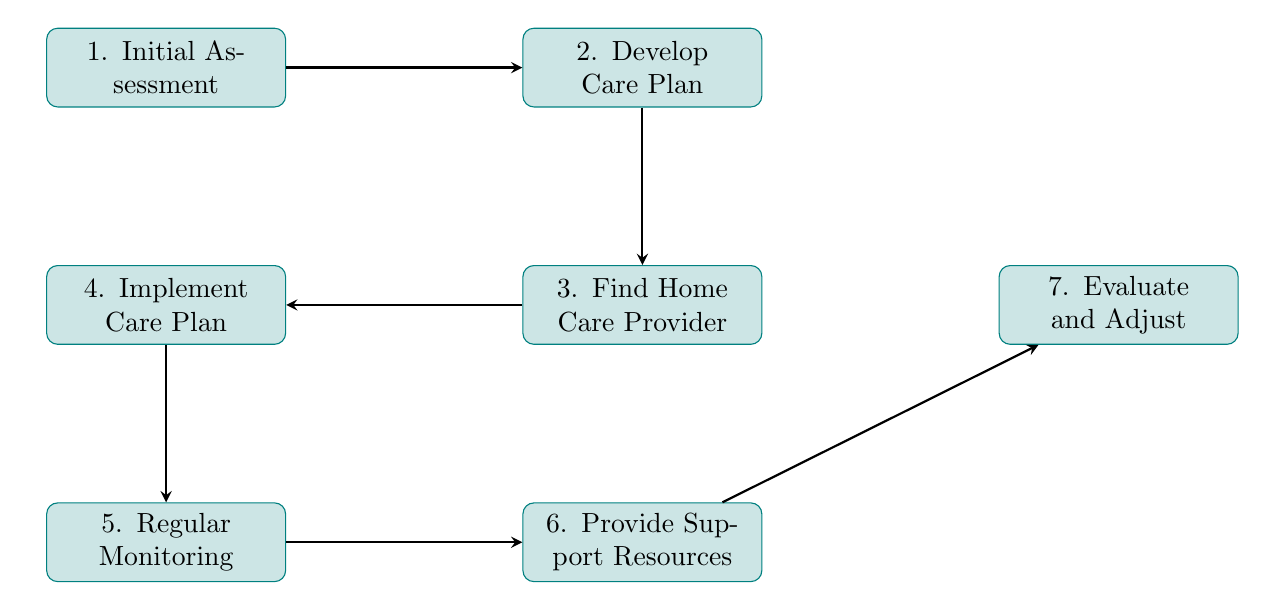What is the first step in the flow chart? The flow chart begins with the "Initial Assessment" node, which is the first step in the process.
Answer: Initial Assessment How many total nodes are in the diagram? There are seven nodes represented in the flow chart, each indicating a distinct step in the process.
Answer: 7 Which step follows "Develop Care Plan"? The step that follows "Develop Care Plan" is "Find Home Care Provider," indicating the progression in the process.
Answer: Find Home Care Provider What is the ultimate goal of the flow chart? The ultimate goal is demonstrated by the last node, "Evaluate and Adjust," which shows the ongoing nature of care coordination.
Answer: Evaluate and Adjust How many edges connect the nodes? The flow chart contains six edges that connect the seven nodes, indicating the relationships and flow between each step.
Answer: 6 What step directly leads to "Regular Monitoring"? The step that directly leads to "Regular Monitoring" is "Implement Care Plan," as indicated by the arrow connecting these two nodes.
Answer: Implement Care Plan Which node provides information about financial assistance? The node labeled "Provide Support Resources" offers information regarding financial assistance programs, support groups, and community resources.
Answer: Provide Support Resources Which steps fall under the monitoring process? The monitoring process involves both "Regular Monitoring" and "Evaluate and Adjust," showcasing the importance of ongoing evaluations in care coordination.
Answer: Regular Monitoring and Evaluate and Adjust 